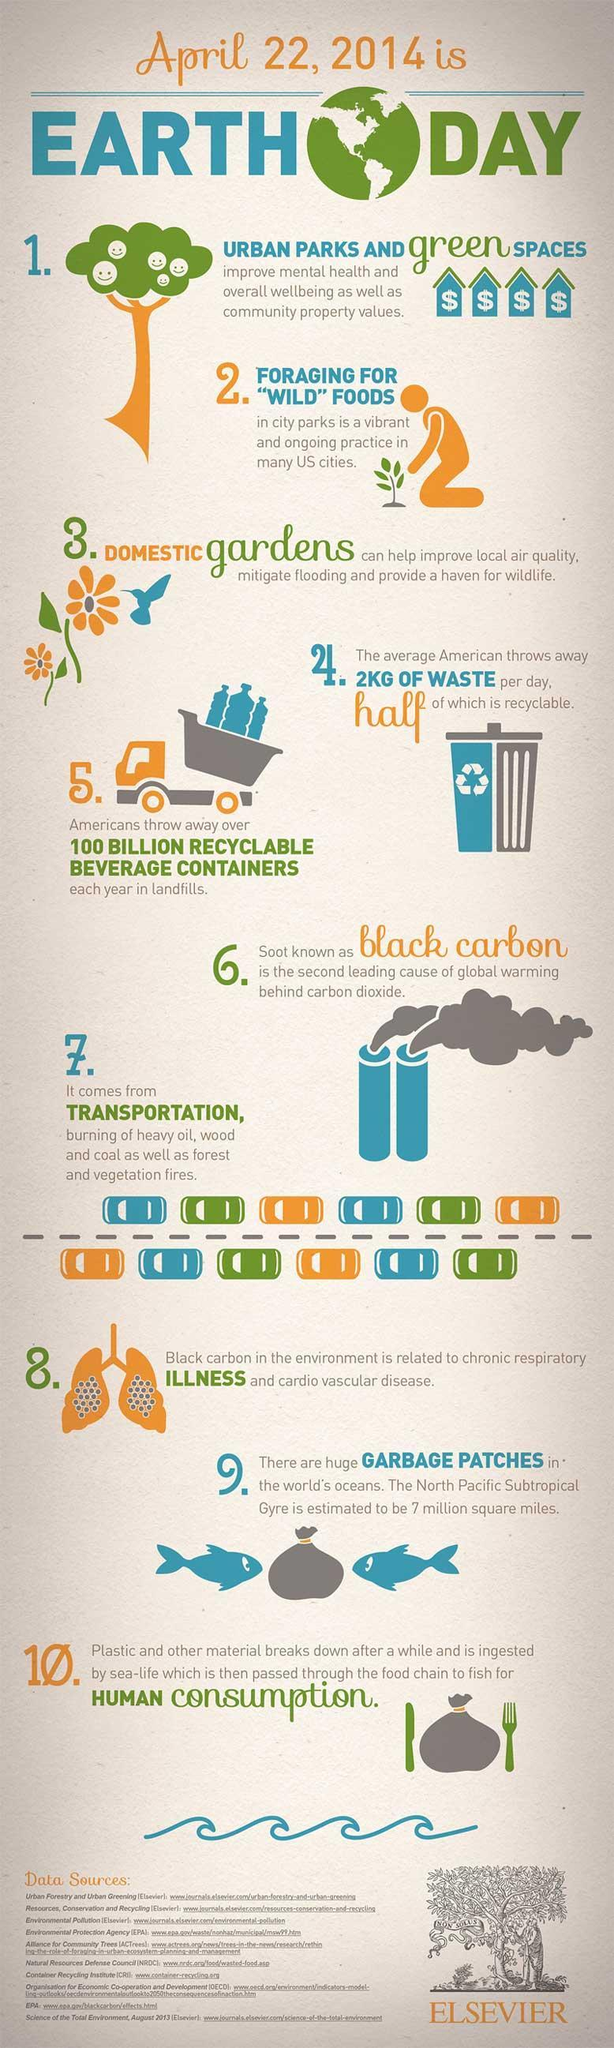How many sources are listed at the bottom?
Answer the question with a short phrase. 10 